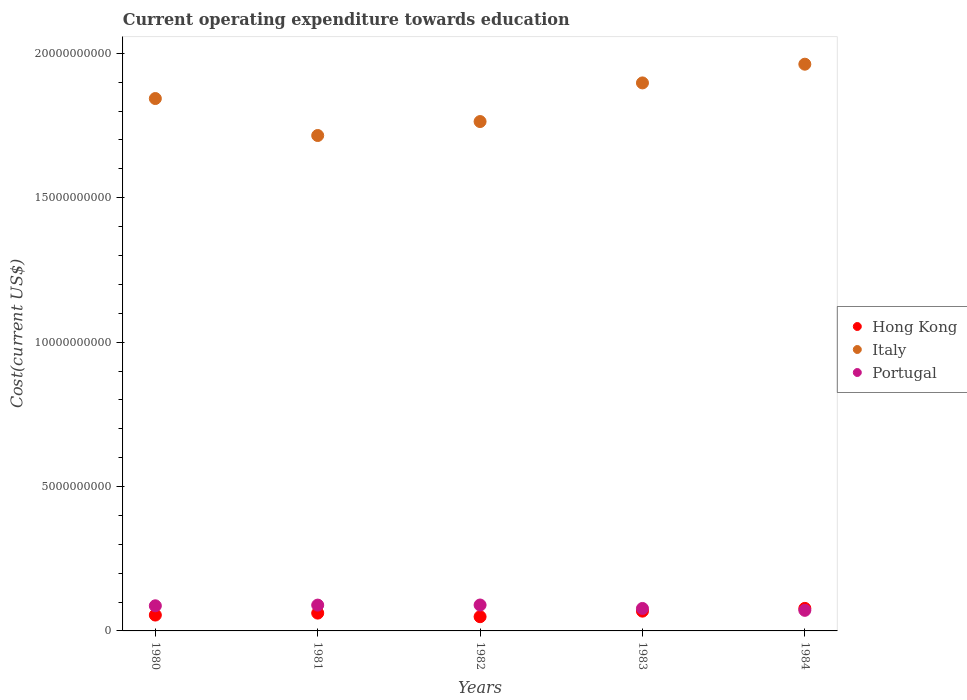How many different coloured dotlines are there?
Your response must be concise. 3. Is the number of dotlines equal to the number of legend labels?
Provide a succinct answer. Yes. What is the expenditure towards education in Hong Kong in 1983?
Your response must be concise. 6.85e+08. Across all years, what is the maximum expenditure towards education in Italy?
Your answer should be compact. 1.96e+1. Across all years, what is the minimum expenditure towards education in Hong Kong?
Your answer should be compact. 4.92e+08. In which year was the expenditure towards education in Hong Kong minimum?
Your response must be concise. 1982. What is the total expenditure towards education in Portugal in the graph?
Ensure brevity in your answer.  4.15e+09. What is the difference between the expenditure towards education in Portugal in 1980 and that in 1982?
Ensure brevity in your answer.  -2.71e+07. What is the difference between the expenditure towards education in Hong Kong in 1983 and the expenditure towards education in Italy in 1980?
Your answer should be compact. -1.78e+1. What is the average expenditure towards education in Italy per year?
Make the answer very short. 1.84e+1. In the year 1984, what is the difference between the expenditure towards education in Portugal and expenditure towards education in Hong Kong?
Ensure brevity in your answer.  -6.71e+07. In how many years, is the expenditure towards education in Portugal greater than 14000000000 US$?
Offer a terse response. 0. What is the ratio of the expenditure towards education in Italy in 1980 to that in 1981?
Keep it short and to the point. 1.07. Is the expenditure towards education in Italy in 1980 less than that in 1984?
Offer a terse response. Yes. Is the difference between the expenditure towards education in Portugal in 1981 and 1983 greater than the difference between the expenditure towards education in Hong Kong in 1981 and 1983?
Your answer should be very brief. Yes. What is the difference between the highest and the second highest expenditure towards education in Portugal?
Your answer should be compact. 3.25e+06. What is the difference between the highest and the lowest expenditure towards education in Hong Kong?
Your answer should be very brief. 2.88e+08. Is the expenditure towards education in Hong Kong strictly less than the expenditure towards education in Italy over the years?
Offer a very short reply. Yes. How many dotlines are there?
Your answer should be very brief. 3. How many years are there in the graph?
Provide a succinct answer. 5. What is the difference between two consecutive major ticks on the Y-axis?
Keep it short and to the point. 5.00e+09. Are the values on the major ticks of Y-axis written in scientific E-notation?
Your response must be concise. No. How are the legend labels stacked?
Provide a short and direct response. Vertical. What is the title of the graph?
Keep it short and to the point. Current operating expenditure towards education. Does "Solomon Islands" appear as one of the legend labels in the graph?
Make the answer very short. No. What is the label or title of the Y-axis?
Your answer should be very brief. Cost(current US$). What is the Cost(current US$) of Hong Kong in 1980?
Provide a short and direct response. 5.49e+08. What is the Cost(current US$) of Italy in 1980?
Ensure brevity in your answer.  1.84e+1. What is the Cost(current US$) of Portugal in 1980?
Offer a very short reply. 8.70e+08. What is the Cost(current US$) in Hong Kong in 1981?
Provide a short and direct response. 6.17e+08. What is the Cost(current US$) in Italy in 1981?
Your answer should be compact. 1.72e+1. What is the Cost(current US$) of Portugal in 1981?
Provide a succinct answer. 8.94e+08. What is the Cost(current US$) of Hong Kong in 1982?
Your response must be concise. 4.92e+08. What is the Cost(current US$) of Italy in 1982?
Offer a terse response. 1.76e+1. What is the Cost(current US$) of Portugal in 1982?
Your answer should be very brief. 8.97e+08. What is the Cost(current US$) of Hong Kong in 1983?
Ensure brevity in your answer.  6.85e+08. What is the Cost(current US$) in Italy in 1983?
Offer a very short reply. 1.90e+1. What is the Cost(current US$) of Portugal in 1983?
Provide a succinct answer. 7.78e+08. What is the Cost(current US$) in Hong Kong in 1984?
Make the answer very short. 7.80e+08. What is the Cost(current US$) in Italy in 1984?
Your response must be concise. 1.96e+1. What is the Cost(current US$) in Portugal in 1984?
Keep it short and to the point. 7.13e+08. Across all years, what is the maximum Cost(current US$) in Hong Kong?
Give a very brief answer. 7.80e+08. Across all years, what is the maximum Cost(current US$) in Italy?
Keep it short and to the point. 1.96e+1. Across all years, what is the maximum Cost(current US$) in Portugal?
Keep it short and to the point. 8.97e+08. Across all years, what is the minimum Cost(current US$) of Hong Kong?
Keep it short and to the point. 4.92e+08. Across all years, what is the minimum Cost(current US$) in Italy?
Offer a very short reply. 1.72e+1. Across all years, what is the minimum Cost(current US$) of Portugal?
Your answer should be very brief. 7.13e+08. What is the total Cost(current US$) of Hong Kong in the graph?
Ensure brevity in your answer.  3.12e+09. What is the total Cost(current US$) of Italy in the graph?
Provide a short and direct response. 9.18e+1. What is the total Cost(current US$) in Portugal in the graph?
Make the answer very short. 4.15e+09. What is the difference between the Cost(current US$) of Hong Kong in 1980 and that in 1981?
Make the answer very short. -6.74e+07. What is the difference between the Cost(current US$) in Italy in 1980 and that in 1981?
Make the answer very short. 1.28e+09. What is the difference between the Cost(current US$) of Portugal in 1980 and that in 1981?
Provide a succinct answer. -2.39e+07. What is the difference between the Cost(current US$) of Hong Kong in 1980 and that in 1982?
Provide a short and direct response. 5.73e+07. What is the difference between the Cost(current US$) of Italy in 1980 and that in 1982?
Your answer should be compact. 7.97e+08. What is the difference between the Cost(current US$) of Portugal in 1980 and that in 1982?
Provide a short and direct response. -2.71e+07. What is the difference between the Cost(current US$) in Hong Kong in 1980 and that in 1983?
Provide a short and direct response. -1.35e+08. What is the difference between the Cost(current US$) of Italy in 1980 and that in 1983?
Your response must be concise. -5.41e+08. What is the difference between the Cost(current US$) of Portugal in 1980 and that in 1983?
Make the answer very short. 9.23e+07. What is the difference between the Cost(current US$) of Hong Kong in 1980 and that in 1984?
Provide a short and direct response. -2.31e+08. What is the difference between the Cost(current US$) of Italy in 1980 and that in 1984?
Your answer should be very brief. -1.19e+09. What is the difference between the Cost(current US$) of Portugal in 1980 and that in 1984?
Keep it short and to the point. 1.57e+08. What is the difference between the Cost(current US$) in Hong Kong in 1981 and that in 1982?
Provide a succinct answer. 1.25e+08. What is the difference between the Cost(current US$) of Italy in 1981 and that in 1982?
Give a very brief answer. -4.83e+08. What is the difference between the Cost(current US$) in Portugal in 1981 and that in 1982?
Your answer should be very brief. -3.25e+06. What is the difference between the Cost(current US$) of Hong Kong in 1981 and that in 1983?
Your answer should be very brief. -6.80e+07. What is the difference between the Cost(current US$) of Italy in 1981 and that in 1983?
Make the answer very short. -1.82e+09. What is the difference between the Cost(current US$) of Portugal in 1981 and that in 1983?
Give a very brief answer. 1.16e+08. What is the difference between the Cost(current US$) in Hong Kong in 1981 and that in 1984?
Your answer should be compact. -1.63e+08. What is the difference between the Cost(current US$) in Italy in 1981 and that in 1984?
Provide a succinct answer. -2.47e+09. What is the difference between the Cost(current US$) of Portugal in 1981 and that in 1984?
Give a very brief answer. 1.81e+08. What is the difference between the Cost(current US$) in Hong Kong in 1982 and that in 1983?
Keep it short and to the point. -1.93e+08. What is the difference between the Cost(current US$) in Italy in 1982 and that in 1983?
Your response must be concise. -1.34e+09. What is the difference between the Cost(current US$) of Portugal in 1982 and that in 1983?
Make the answer very short. 1.19e+08. What is the difference between the Cost(current US$) in Hong Kong in 1982 and that in 1984?
Offer a very short reply. -2.88e+08. What is the difference between the Cost(current US$) in Italy in 1982 and that in 1984?
Keep it short and to the point. -1.99e+09. What is the difference between the Cost(current US$) of Portugal in 1982 and that in 1984?
Give a very brief answer. 1.85e+08. What is the difference between the Cost(current US$) of Hong Kong in 1983 and that in 1984?
Your answer should be very brief. -9.52e+07. What is the difference between the Cost(current US$) of Italy in 1983 and that in 1984?
Offer a terse response. -6.48e+08. What is the difference between the Cost(current US$) of Portugal in 1983 and that in 1984?
Your answer should be very brief. 6.50e+07. What is the difference between the Cost(current US$) in Hong Kong in 1980 and the Cost(current US$) in Italy in 1981?
Your response must be concise. -1.66e+1. What is the difference between the Cost(current US$) of Hong Kong in 1980 and the Cost(current US$) of Portugal in 1981?
Your response must be concise. -3.45e+08. What is the difference between the Cost(current US$) in Italy in 1980 and the Cost(current US$) in Portugal in 1981?
Provide a succinct answer. 1.75e+1. What is the difference between the Cost(current US$) in Hong Kong in 1980 and the Cost(current US$) in Italy in 1982?
Your response must be concise. -1.71e+1. What is the difference between the Cost(current US$) in Hong Kong in 1980 and the Cost(current US$) in Portugal in 1982?
Give a very brief answer. -3.48e+08. What is the difference between the Cost(current US$) of Italy in 1980 and the Cost(current US$) of Portugal in 1982?
Your answer should be very brief. 1.75e+1. What is the difference between the Cost(current US$) in Hong Kong in 1980 and the Cost(current US$) in Italy in 1983?
Provide a short and direct response. -1.84e+1. What is the difference between the Cost(current US$) in Hong Kong in 1980 and the Cost(current US$) in Portugal in 1983?
Make the answer very short. -2.29e+08. What is the difference between the Cost(current US$) in Italy in 1980 and the Cost(current US$) in Portugal in 1983?
Make the answer very short. 1.77e+1. What is the difference between the Cost(current US$) of Hong Kong in 1980 and the Cost(current US$) of Italy in 1984?
Make the answer very short. -1.91e+1. What is the difference between the Cost(current US$) of Hong Kong in 1980 and the Cost(current US$) of Portugal in 1984?
Your answer should be very brief. -1.64e+08. What is the difference between the Cost(current US$) in Italy in 1980 and the Cost(current US$) in Portugal in 1984?
Provide a succinct answer. 1.77e+1. What is the difference between the Cost(current US$) of Hong Kong in 1981 and the Cost(current US$) of Italy in 1982?
Make the answer very short. -1.70e+1. What is the difference between the Cost(current US$) in Hong Kong in 1981 and the Cost(current US$) in Portugal in 1982?
Provide a succinct answer. -2.81e+08. What is the difference between the Cost(current US$) of Italy in 1981 and the Cost(current US$) of Portugal in 1982?
Your response must be concise. 1.63e+1. What is the difference between the Cost(current US$) in Hong Kong in 1981 and the Cost(current US$) in Italy in 1983?
Keep it short and to the point. -1.84e+1. What is the difference between the Cost(current US$) of Hong Kong in 1981 and the Cost(current US$) of Portugal in 1983?
Your answer should be compact. -1.61e+08. What is the difference between the Cost(current US$) of Italy in 1981 and the Cost(current US$) of Portugal in 1983?
Keep it short and to the point. 1.64e+1. What is the difference between the Cost(current US$) in Hong Kong in 1981 and the Cost(current US$) in Italy in 1984?
Provide a short and direct response. -1.90e+1. What is the difference between the Cost(current US$) of Hong Kong in 1981 and the Cost(current US$) of Portugal in 1984?
Your answer should be compact. -9.61e+07. What is the difference between the Cost(current US$) in Italy in 1981 and the Cost(current US$) in Portugal in 1984?
Make the answer very short. 1.64e+1. What is the difference between the Cost(current US$) of Hong Kong in 1982 and the Cost(current US$) of Italy in 1983?
Keep it short and to the point. -1.85e+1. What is the difference between the Cost(current US$) in Hong Kong in 1982 and the Cost(current US$) in Portugal in 1983?
Your answer should be compact. -2.86e+08. What is the difference between the Cost(current US$) in Italy in 1982 and the Cost(current US$) in Portugal in 1983?
Your answer should be compact. 1.69e+1. What is the difference between the Cost(current US$) in Hong Kong in 1982 and the Cost(current US$) in Italy in 1984?
Offer a very short reply. -1.91e+1. What is the difference between the Cost(current US$) of Hong Kong in 1982 and the Cost(current US$) of Portugal in 1984?
Your answer should be compact. -2.21e+08. What is the difference between the Cost(current US$) in Italy in 1982 and the Cost(current US$) in Portugal in 1984?
Provide a short and direct response. 1.69e+1. What is the difference between the Cost(current US$) in Hong Kong in 1983 and the Cost(current US$) in Italy in 1984?
Give a very brief answer. -1.89e+1. What is the difference between the Cost(current US$) of Hong Kong in 1983 and the Cost(current US$) of Portugal in 1984?
Ensure brevity in your answer.  -2.81e+07. What is the difference between the Cost(current US$) in Italy in 1983 and the Cost(current US$) in Portugal in 1984?
Provide a succinct answer. 1.83e+1. What is the average Cost(current US$) of Hong Kong per year?
Your answer should be compact. 6.25e+08. What is the average Cost(current US$) in Italy per year?
Your response must be concise. 1.84e+1. What is the average Cost(current US$) of Portugal per year?
Offer a very short reply. 8.30e+08. In the year 1980, what is the difference between the Cost(current US$) of Hong Kong and Cost(current US$) of Italy?
Your answer should be very brief. -1.79e+1. In the year 1980, what is the difference between the Cost(current US$) in Hong Kong and Cost(current US$) in Portugal?
Offer a very short reply. -3.21e+08. In the year 1980, what is the difference between the Cost(current US$) in Italy and Cost(current US$) in Portugal?
Offer a very short reply. 1.76e+1. In the year 1981, what is the difference between the Cost(current US$) of Hong Kong and Cost(current US$) of Italy?
Make the answer very short. -1.65e+1. In the year 1981, what is the difference between the Cost(current US$) of Hong Kong and Cost(current US$) of Portugal?
Your answer should be compact. -2.77e+08. In the year 1981, what is the difference between the Cost(current US$) of Italy and Cost(current US$) of Portugal?
Your answer should be very brief. 1.63e+1. In the year 1982, what is the difference between the Cost(current US$) of Hong Kong and Cost(current US$) of Italy?
Make the answer very short. -1.71e+1. In the year 1982, what is the difference between the Cost(current US$) in Hong Kong and Cost(current US$) in Portugal?
Offer a very short reply. -4.05e+08. In the year 1982, what is the difference between the Cost(current US$) of Italy and Cost(current US$) of Portugal?
Offer a terse response. 1.67e+1. In the year 1983, what is the difference between the Cost(current US$) in Hong Kong and Cost(current US$) in Italy?
Give a very brief answer. -1.83e+1. In the year 1983, what is the difference between the Cost(current US$) of Hong Kong and Cost(current US$) of Portugal?
Give a very brief answer. -9.31e+07. In the year 1983, what is the difference between the Cost(current US$) in Italy and Cost(current US$) in Portugal?
Give a very brief answer. 1.82e+1. In the year 1984, what is the difference between the Cost(current US$) of Hong Kong and Cost(current US$) of Italy?
Provide a succinct answer. -1.88e+1. In the year 1984, what is the difference between the Cost(current US$) of Hong Kong and Cost(current US$) of Portugal?
Provide a short and direct response. 6.71e+07. In the year 1984, what is the difference between the Cost(current US$) of Italy and Cost(current US$) of Portugal?
Provide a succinct answer. 1.89e+1. What is the ratio of the Cost(current US$) in Hong Kong in 1980 to that in 1981?
Your answer should be very brief. 0.89. What is the ratio of the Cost(current US$) of Italy in 1980 to that in 1981?
Provide a short and direct response. 1.07. What is the ratio of the Cost(current US$) in Portugal in 1980 to that in 1981?
Make the answer very short. 0.97. What is the ratio of the Cost(current US$) of Hong Kong in 1980 to that in 1982?
Keep it short and to the point. 1.12. What is the ratio of the Cost(current US$) in Italy in 1980 to that in 1982?
Provide a short and direct response. 1.05. What is the ratio of the Cost(current US$) in Portugal in 1980 to that in 1982?
Your answer should be compact. 0.97. What is the ratio of the Cost(current US$) in Hong Kong in 1980 to that in 1983?
Ensure brevity in your answer.  0.8. What is the ratio of the Cost(current US$) of Italy in 1980 to that in 1983?
Ensure brevity in your answer.  0.97. What is the ratio of the Cost(current US$) of Portugal in 1980 to that in 1983?
Your answer should be very brief. 1.12. What is the ratio of the Cost(current US$) of Hong Kong in 1980 to that in 1984?
Your response must be concise. 0.7. What is the ratio of the Cost(current US$) in Italy in 1980 to that in 1984?
Keep it short and to the point. 0.94. What is the ratio of the Cost(current US$) of Portugal in 1980 to that in 1984?
Provide a succinct answer. 1.22. What is the ratio of the Cost(current US$) in Hong Kong in 1981 to that in 1982?
Provide a succinct answer. 1.25. What is the ratio of the Cost(current US$) in Italy in 1981 to that in 1982?
Ensure brevity in your answer.  0.97. What is the ratio of the Cost(current US$) in Portugal in 1981 to that in 1982?
Ensure brevity in your answer.  1. What is the ratio of the Cost(current US$) of Hong Kong in 1981 to that in 1983?
Make the answer very short. 0.9. What is the ratio of the Cost(current US$) of Italy in 1981 to that in 1983?
Offer a very short reply. 0.9. What is the ratio of the Cost(current US$) in Portugal in 1981 to that in 1983?
Provide a short and direct response. 1.15. What is the ratio of the Cost(current US$) in Hong Kong in 1981 to that in 1984?
Offer a very short reply. 0.79. What is the ratio of the Cost(current US$) in Italy in 1981 to that in 1984?
Ensure brevity in your answer.  0.87. What is the ratio of the Cost(current US$) in Portugal in 1981 to that in 1984?
Your answer should be very brief. 1.25. What is the ratio of the Cost(current US$) in Hong Kong in 1982 to that in 1983?
Give a very brief answer. 0.72. What is the ratio of the Cost(current US$) of Italy in 1982 to that in 1983?
Give a very brief answer. 0.93. What is the ratio of the Cost(current US$) in Portugal in 1982 to that in 1983?
Your answer should be compact. 1.15. What is the ratio of the Cost(current US$) in Hong Kong in 1982 to that in 1984?
Give a very brief answer. 0.63. What is the ratio of the Cost(current US$) in Italy in 1982 to that in 1984?
Provide a succinct answer. 0.9. What is the ratio of the Cost(current US$) of Portugal in 1982 to that in 1984?
Your answer should be very brief. 1.26. What is the ratio of the Cost(current US$) of Hong Kong in 1983 to that in 1984?
Your response must be concise. 0.88. What is the ratio of the Cost(current US$) of Italy in 1983 to that in 1984?
Make the answer very short. 0.97. What is the ratio of the Cost(current US$) in Portugal in 1983 to that in 1984?
Your answer should be very brief. 1.09. What is the difference between the highest and the second highest Cost(current US$) in Hong Kong?
Ensure brevity in your answer.  9.52e+07. What is the difference between the highest and the second highest Cost(current US$) in Italy?
Your response must be concise. 6.48e+08. What is the difference between the highest and the second highest Cost(current US$) in Portugal?
Provide a short and direct response. 3.25e+06. What is the difference between the highest and the lowest Cost(current US$) in Hong Kong?
Provide a succinct answer. 2.88e+08. What is the difference between the highest and the lowest Cost(current US$) of Italy?
Give a very brief answer. 2.47e+09. What is the difference between the highest and the lowest Cost(current US$) of Portugal?
Make the answer very short. 1.85e+08. 